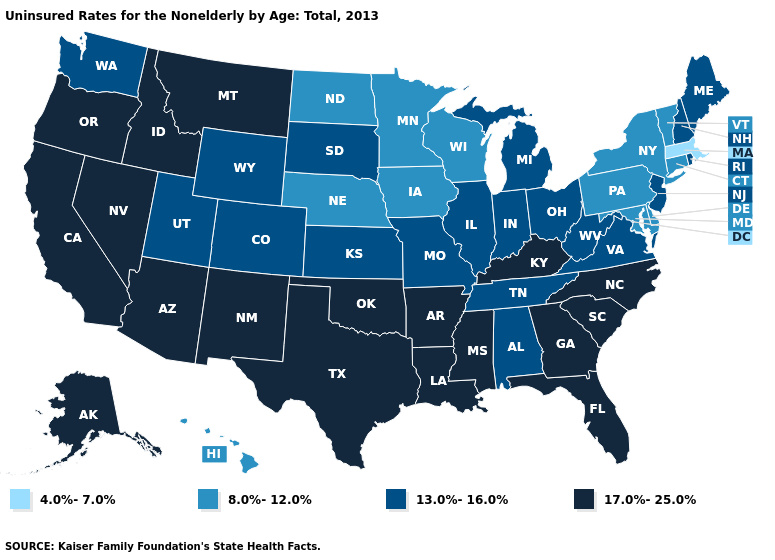What is the highest value in the South ?
Answer briefly. 17.0%-25.0%. What is the value of South Carolina?
Short answer required. 17.0%-25.0%. What is the value of Nevada?
Be succinct. 17.0%-25.0%. Name the states that have a value in the range 8.0%-12.0%?
Answer briefly. Connecticut, Delaware, Hawaii, Iowa, Maryland, Minnesota, Nebraska, New York, North Dakota, Pennsylvania, Vermont, Wisconsin. Name the states that have a value in the range 4.0%-7.0%?
Keep it brief. Massachusetts. Does Minnesota have the same value as North Dakota?
Be succinct. Yes. Among the states that border Massachusetts , does Rhode Island have the highest value?
Quick response, please. Yes. How many symbols are there in the legend?
Concise answer only. 4. Is the legend a continuous bar?
Answer briefly. No. Which states have the lowest value in the USA?
Write a very short answer. Massachusetts. Which states hav the highest value in the Northeast?
Give a very brief answer. Maine, New Hampshire, New Jersey, Rhode Island. Among the states that border Tennessee , does Alabama have the lowest value?
Write a very short answer. Yes. Does New Jersey have the lowest value in the Northeast?
Concise answer only. No. What is the value of Illinois?
Quick response, please. 13.0%-16.0%. What is the value of Wyoming?
Write a very short answer. 13.0%-16.0%. 